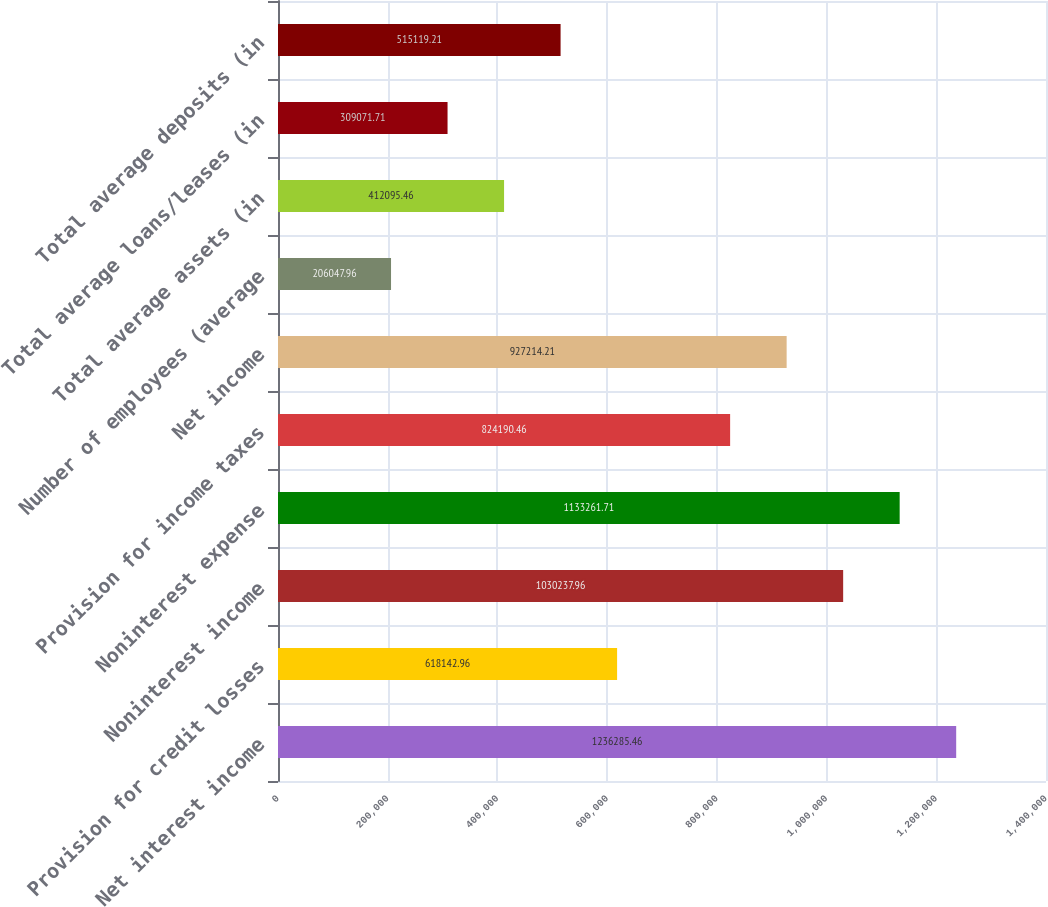Convert chart. <chart><loc_0><loc_0><loc_500><loc_500><bar_chart><fcel>Net interest income<fcel>Provision for credit losses<fcel>Noninterest income<fcel>Noninterest expense<fcel>Provision for income taxes<fcel>Net income<fcel>Number of employees (average<fcel>Total average assets (in<fcel>Total average loans/leases (in<fcel>Total average deposits (in<nl><fcel>1.23629e+06<fcel>618143<fcel>1.03024e+06<fcel>1.13326e+06<fcel>824190<fcel>927214<fcel>206048<fcel>412095<fcel>309072<fcel>515119<nl></chart> 